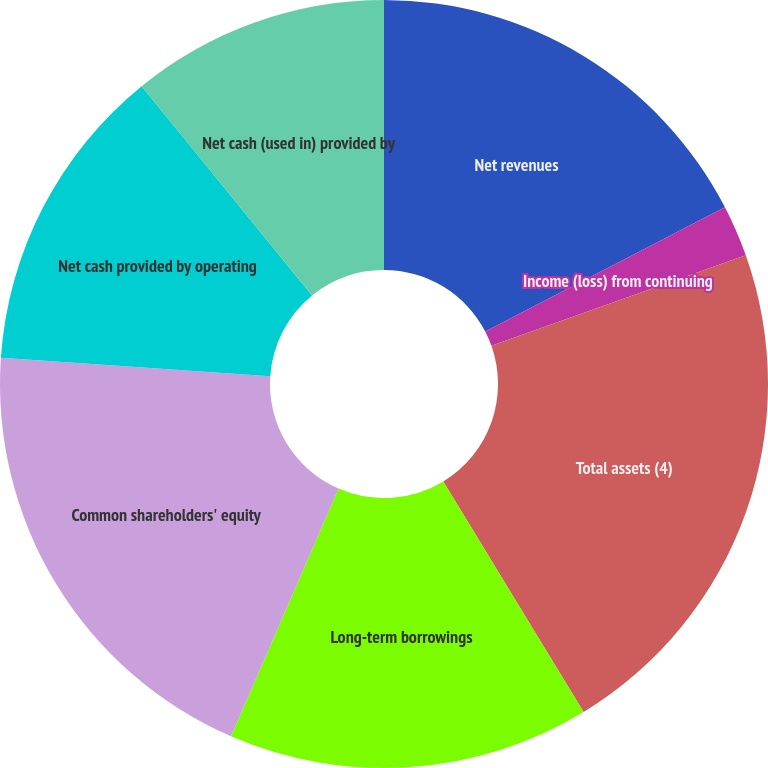Convert chart. <chart><loc_0><loc_0><loc_500><loc_500><pie_chart><fcel>Net revenues<fcel>Income (loss) from continuing<fcel>Cash dividends<fcel>Total assets (4)<fcel>Long-term borrowings<fcel>Common shareholders' equity<fcel>Net cash provided by operating<fcel>Net cash (used in) provided by<nl><fcel>17.39%<fcel>2.17%<fcel>0.0%<fcel>21.74%<fcel>15.22%<fcel>19.57%<fcel>13.04%<fcel>10.87%<nl></chart> 